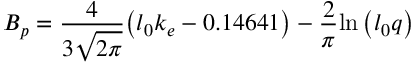<formula> <loc_0><loc_0><loc_500><loc_500>B _ { p } = \frac { 4 } { 3 \sqrt { 2 \pi } } { \left ( l _ { 0 } k _ { e } - 0 . 1 4 6 4 1 \right ) - \frac { 2 } { \pi } { \ln { \left ( l _ { 0 } q \right ) } } }</formula> 